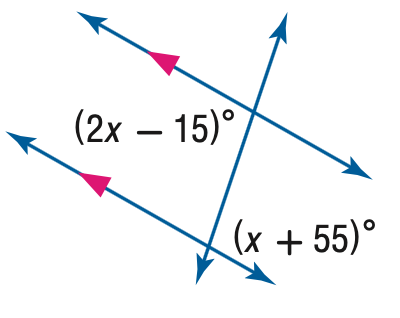Answer the mathemtical geometry problem and directly provide the correct option letter.
Question: Find the value of the variable x in the figure.
Choices: A: 46.7 B: 60 C: 70 D: 80 C 